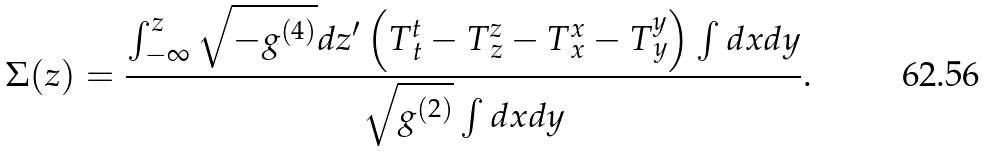Convert formula to latex. <formula><loc_0><loc_0><loc_500><loc_500>\Sigma ( z ) = \frac { \int _ { - \infty } ^ { z } \sqrt { - g ^ { ( 4 ) } } d z ^ { \prime } \left ( T _ { \, t } ^ { t } - T _ { \, z } ^ { z } - T _ { \, x } ^ { x } - T _ { \, y } ^ { y } \right ) \int d x d y } { \sqrt { g ^ { ( 2 ) } } \int d x d y } .</formula> 